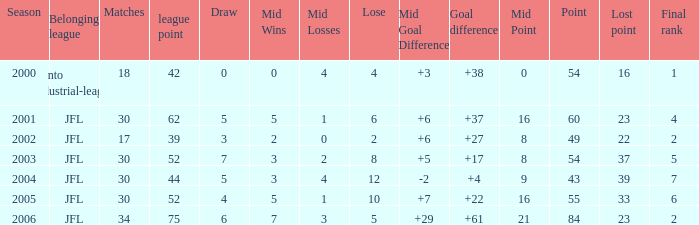I want the total number of matches for draw less than 7 and lost point of 16 with lose more than 4 0.0. 